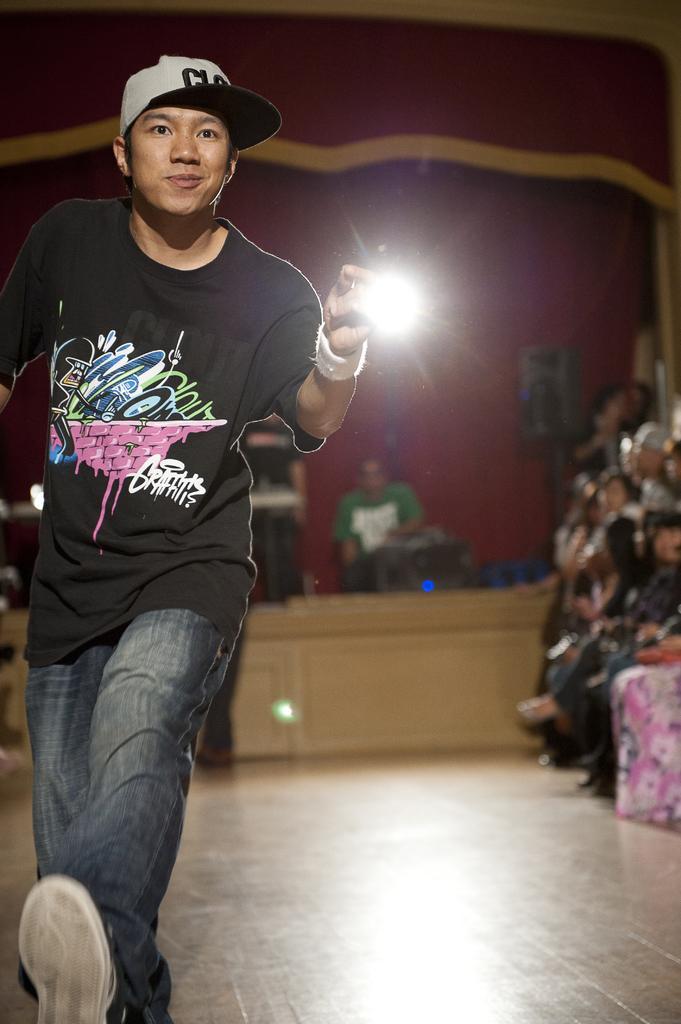Could you give a brief overview of what you see in this image? There is a boy, it seems like holding an object in his hand, there are other people and some objects in the background. 